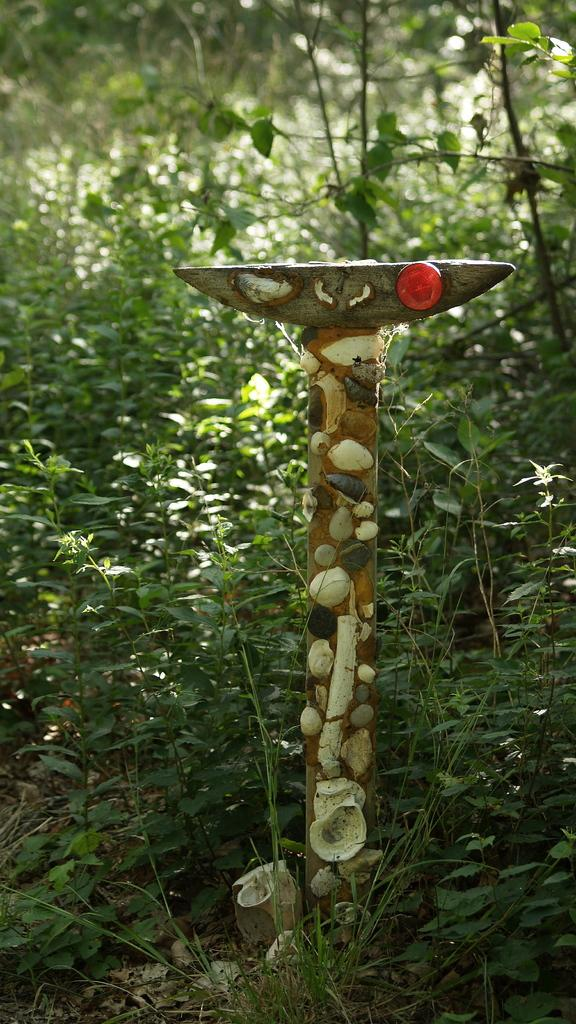What type of animals are on an object in the image? There are seals on an object in the image. What can be seen in the background of the image? There are plants in the background of the image. What type of dress is the seal wearing in the image? Seals do not wear dresses, as they are animals and not human beings. What type of writing can be seen on the object the seals are on? There is no writing visible on the object the seals are on in the image. 